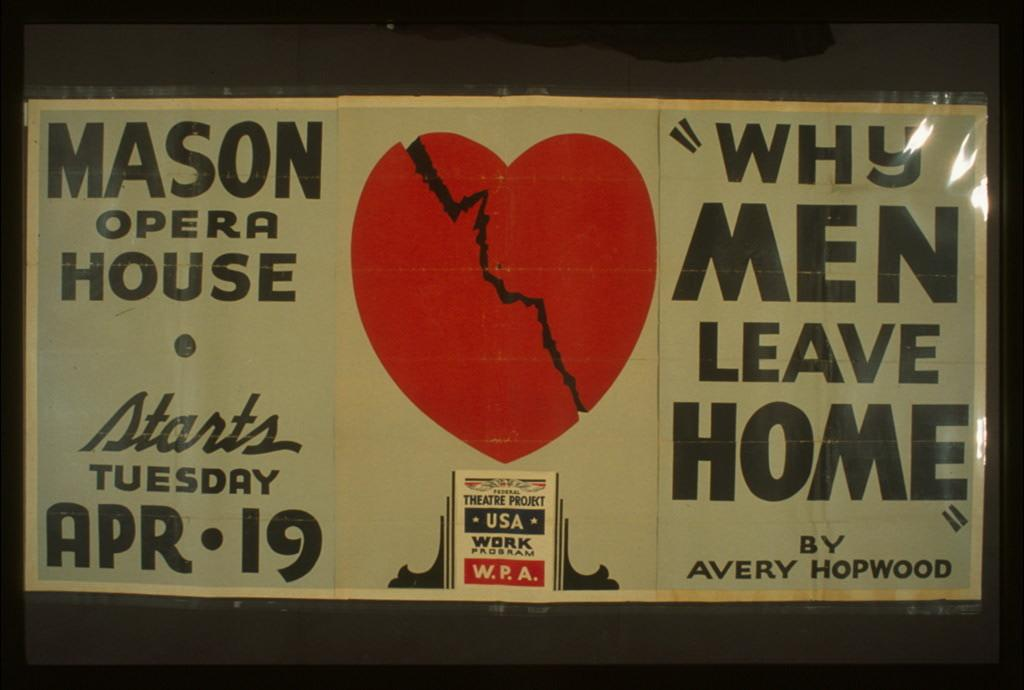<image>
Give a short and clear explanation of the subsequent image. Sign that says Why Men Leave Home with a broken heart. 